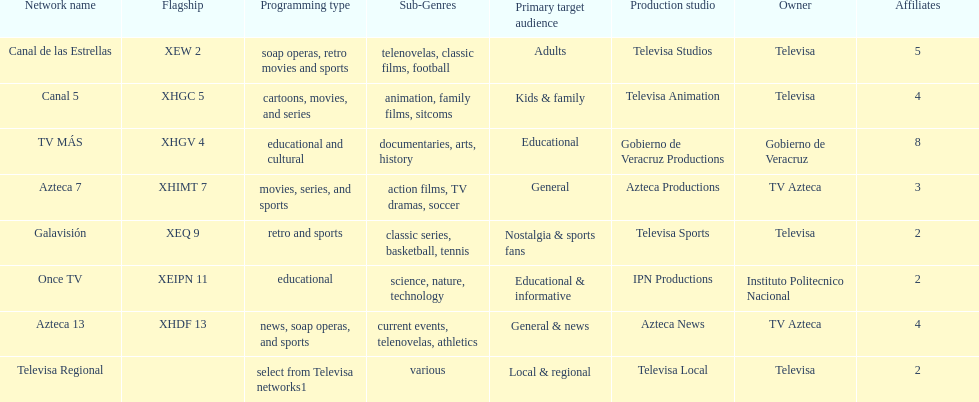Which is the only station with 8 affiliates? TV MÁS. 